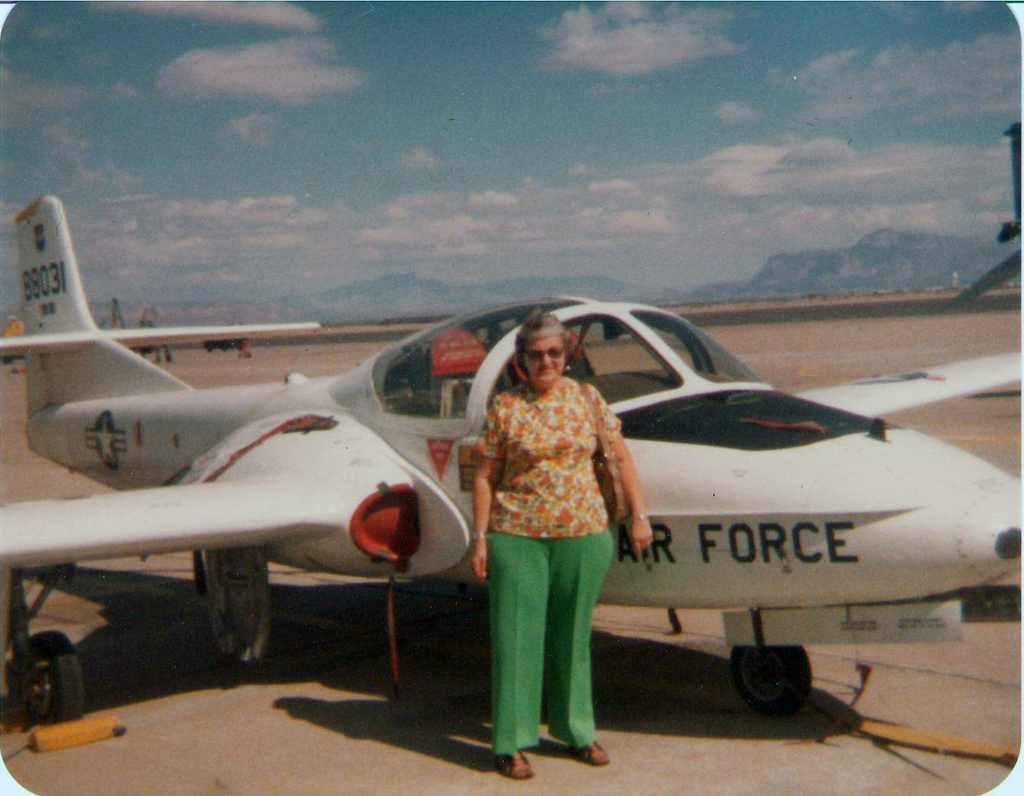Provide a one-sentence caption for the provided image. A woman stands confidently beside a T-37 Tweet trainer aircraft on a sunny day, highlighting her connection to the Air Force, set against a backdrop of distant mountains under a clear sky. 